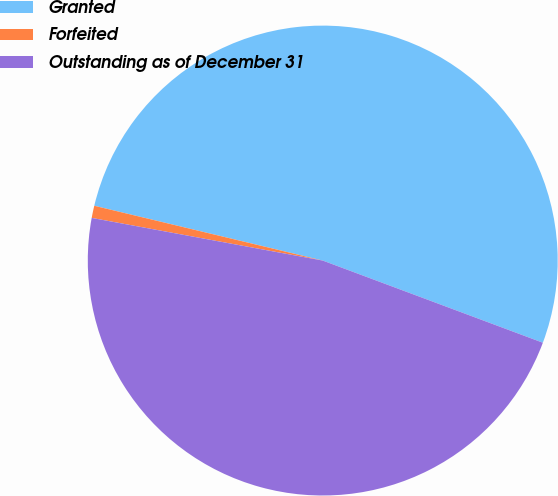Convert chart to OTSL. <chart><loc_0><loc_0><loc_500><loc_500><pie_chart><fcel>Granted<fcel>Forfeited<fcel>Outstanding as of December 31<nl><fcel>51.94%<fcel>0.84%<fcel>47.22%<nl></chart> 